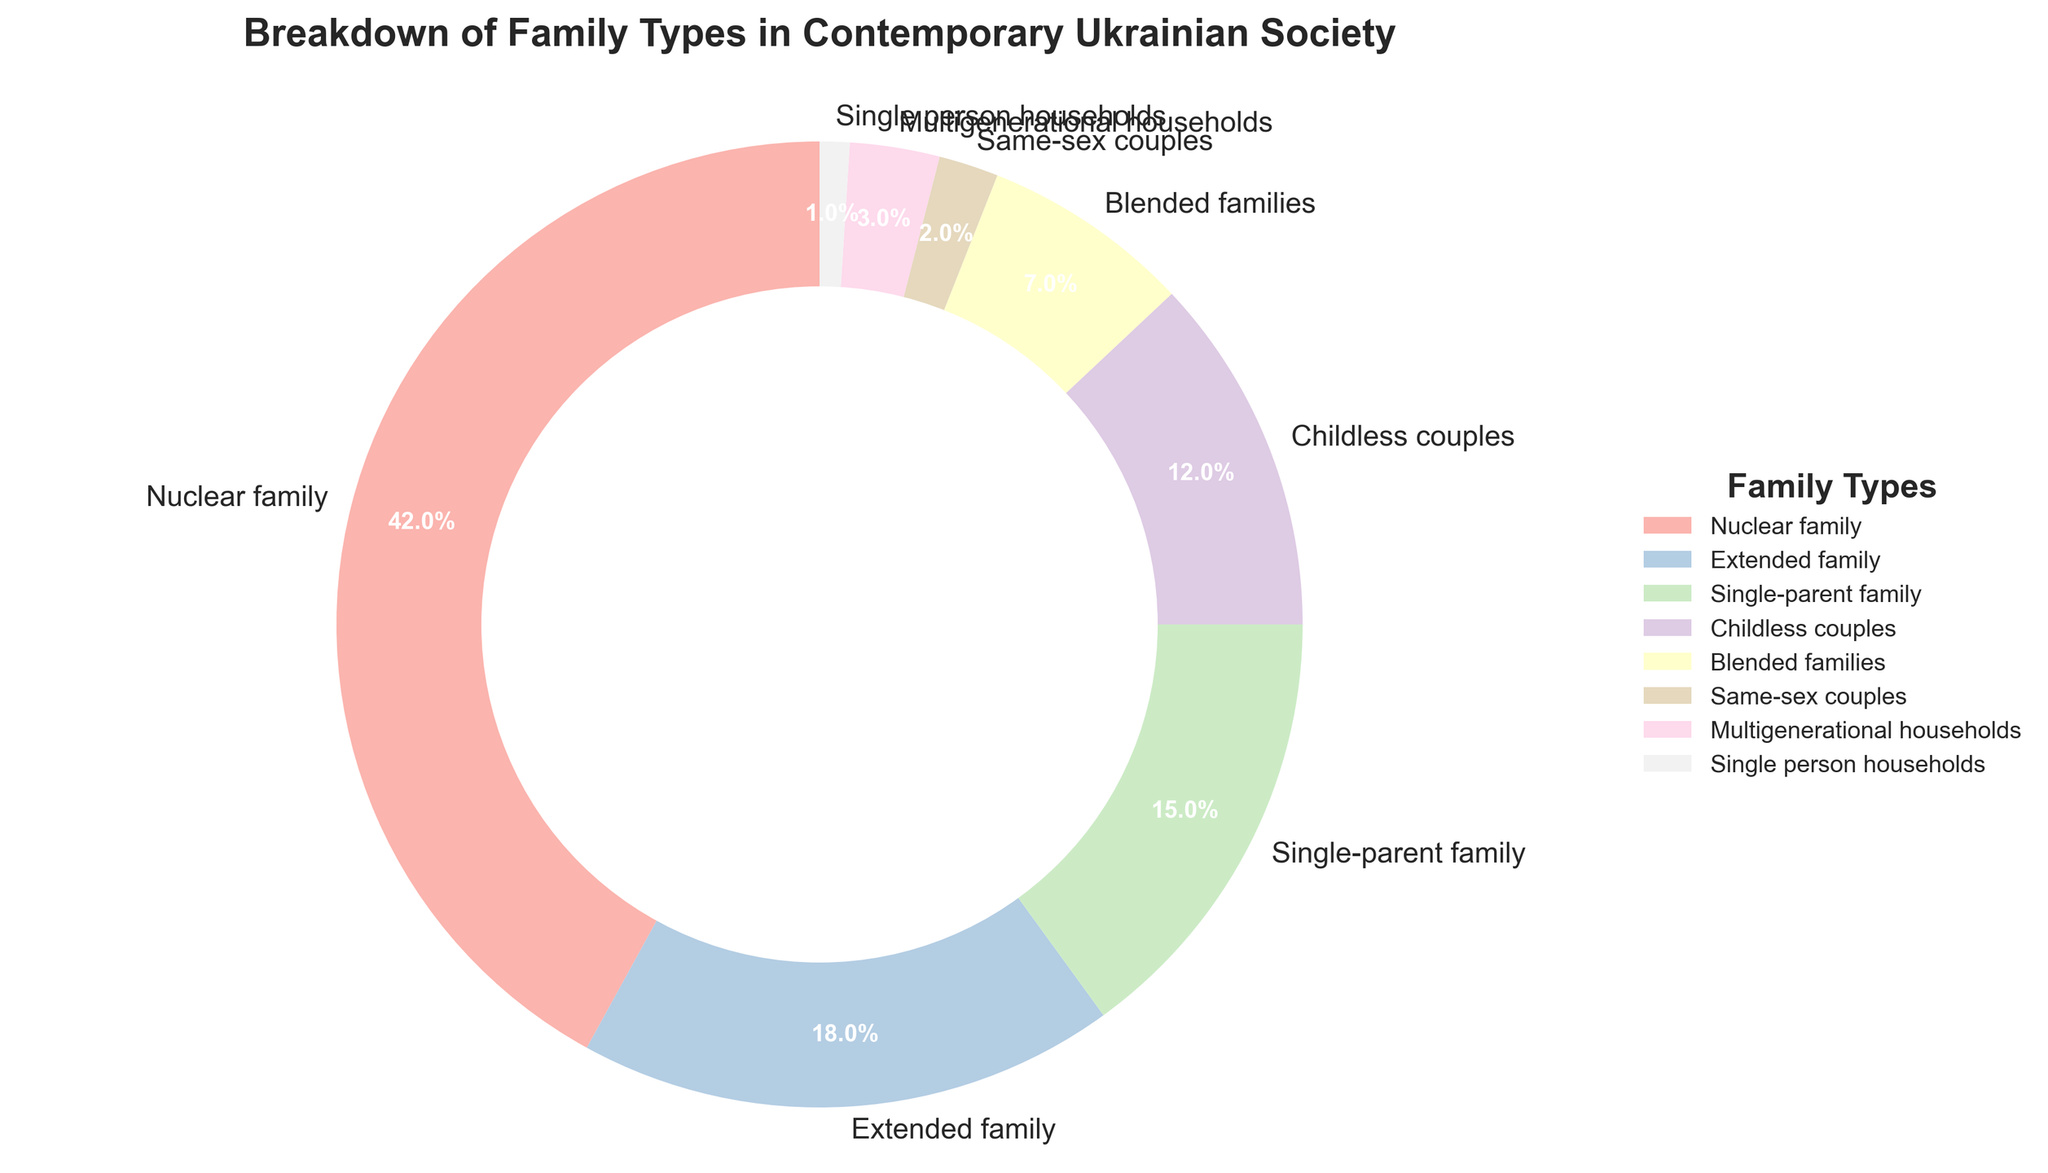Which family type has the highest percentage? To find out which family type has the highest percentage, look for the largest segment in the pie chart. The "Nuclear family" is the largest segment.
Answer: Nuclear family What is the total percentage of single-parent families and childless couples? To find the combined percentage, add the percentages of single-parent families (15%) and childless couples (12%). 15% + 12% = 27%
Answer: 27% Which family type has a greater percentage: same-sex couples or single person households? Compare the percentages of same-sex couples (2%) and single person households (1%). 2% > 1%, so same-sex couples have a greater percentage.
Answer: Same-sex couples What is the percentage difference between nuclear families and extended families? Subtract the percentage of extended families (18%) from nuclear families (42%). 42% - 18% = 24%
Answer: 24% How many family types have a percentage less than 10%? Identify the segments with less than 10%: Blended families (7%), Same-sex couples (2%), Multigenerational households (3%), and Single person households (1%). Counting these types, there are 4 family types.
Answer: 4 If the percentages of single-parent families and childless couples were combined, what would be their rank among all family types? Combine the percentages of single-parent families (15%) and childless couples (12%) to get 27%. Compare 27% with other family types' percentages: 42% (Nuclear), 18% (Extended), 15% (Single-parent), 12% (Childless), 7% (Blended), 3% (Multigenerational), 2% (Same-sex), 1% (Single person). 27% would be the second highest.
Answer: Second highest Which family type uses the lightest color? Visual inspection of the pie chart shows that the segment representing "Same-sex couples" uses the lightest color.
Answer: Same-sex couples What is the combined percentage of blended families and multigenerational households? Add the percentages of blended families (7%) and multigenerational households (3%). 7% + 3% = 10%
Answer: 10% What is the percentage of family types representing non-traditional arrangements (e.g., blended, same-sex, single person households)? Add the percentages of blended families (7%), same-sex couples (2%), and single person households (1%). 7% + 2% + 1% = 10%
Answer: 10% Which family type occupies the second-largest segment in the pie chart? Visual inspection reveals the second-largest segment represents "Extended family" at 18%.
Answer: Extended family 